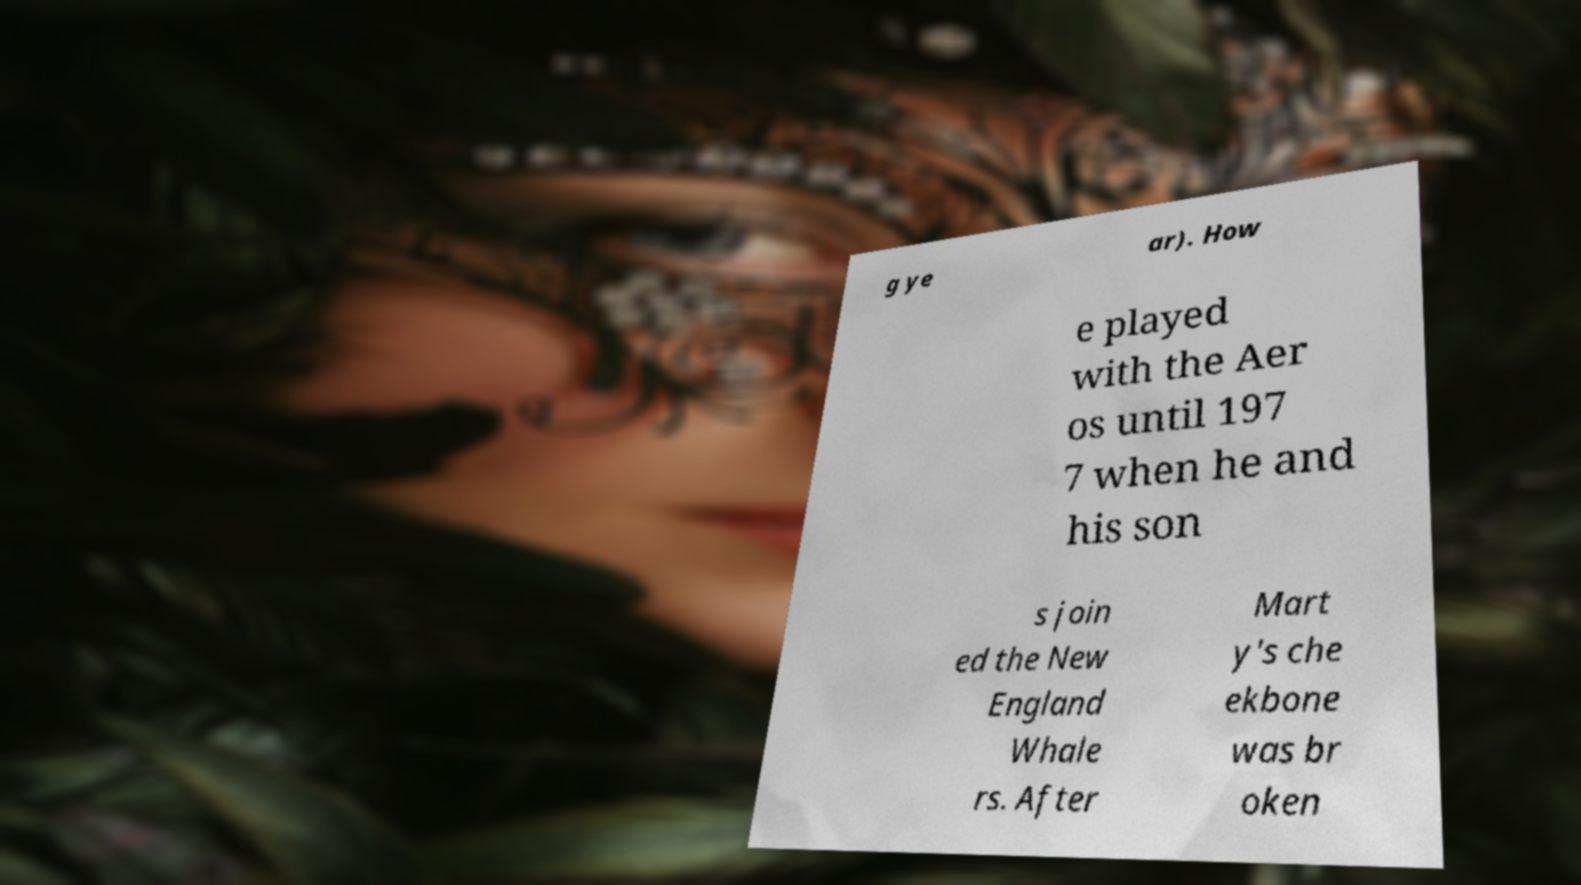Could you extract and type out the text from this image? Certainly! The text on the paper in the image reads, 'How he played with the Aeros until 1977 when he and his sons joined the New England Whalers. After Marty's cheekbone was broken.' 